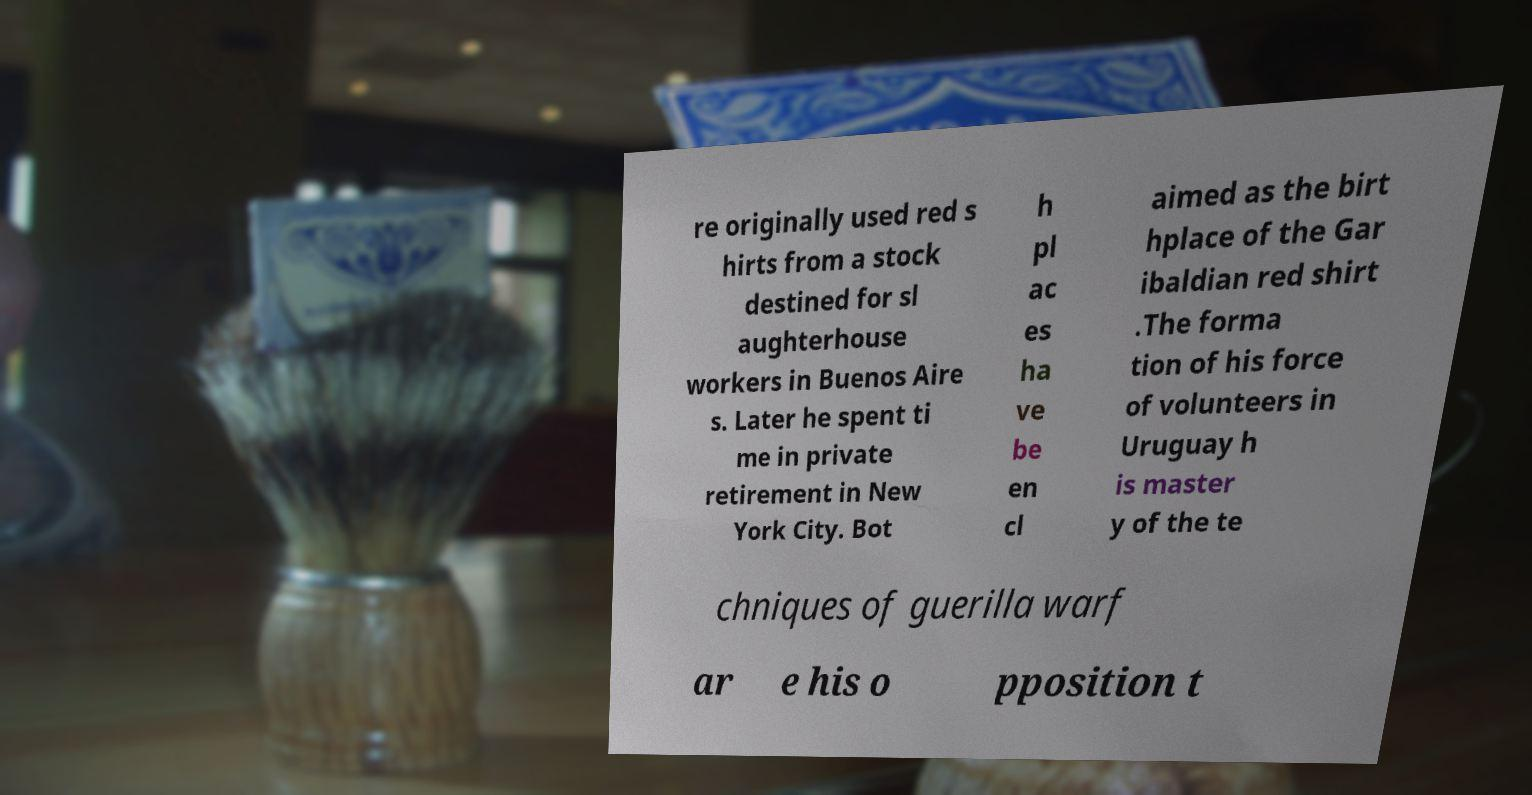Could you extract and type out the text from this image? re originally used red s hirts from a stock destined for sl aughterhouse workers in Buenos Aire s. Later he spent ti me in private retirement in New York City. Bot h pl ac es ha ve be en cl aimed as the birt hplace of the Gar ibaldian red shirt .The forma tion of his force of volunteers in Uruguay h is master y of the te chniques of guerilla warf ar e his o pposition t 